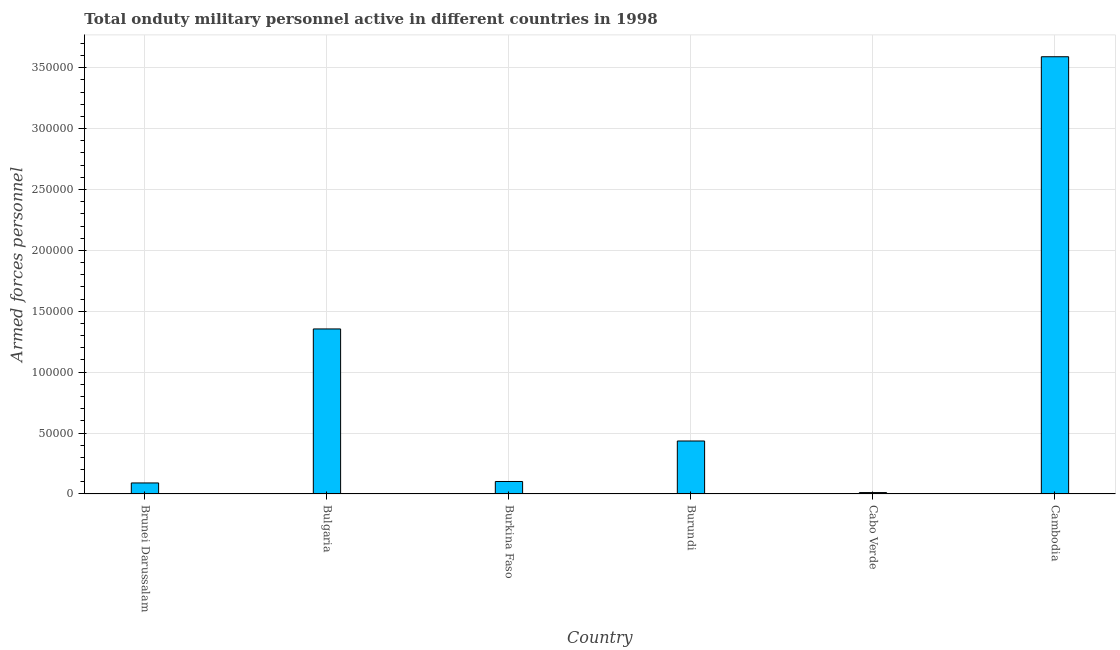Does the graph contain any zero values?
Give a very brief answer. No. What is the title of the graph?
Give a very brief answer. Total onduty military personnel active in different countries in 1998. What is the label or title of the X-axis?
Ensure brevity in your answer.  Country. What is the label or title of the Y-axis?
Provide a short and direct response. Armed forces personnel. What is the number of armed forces personnel in Cabo Verde?
Make the answer very short. 1150. Across all countries, what is the maximum number of armed forces personnel?
Ensure brevity in your answer.  3.59e+05. Across all countries, what is the minimum number of armed forces personnel?
Ensure brevity in your answer.  1150. In which country was the number of armed forces personnel maximum?
Offer a terse response. Cambodia. In which country was the number of armed forces personnel minimum?
Your answer should be very brief. Cabo Verde. What is the sum of the number of armed forces personnel?
Offer a terse response. 5.58e+05. What is the difference between the number of armed forces personnel in Brunei Darussalam and Burundi?
Your answer should be compact. -3.44e+04. What is the average number of armed forces personnel per country?
Offer a terse response. 9.31e+04. What is the median number of armed forces personnel?
Provide a short and direct response. 2.69e+04. What is the ratio of the number of armed forces personnel in Burkina Faso to that in Cabo Verde?
Your answer should be very brief. 8.91. What is the difference between the highest and the second highest number of armed forces personnel?
Your answer should be very brief. 2.24e+05. Is the sum of the number of armed forces personnel in Burundi and Cabo Verde greater than the maximum number of armed forces personnel across all countries?
Give a very brief answer. No. What is the difference between the highest and the lowest number of armed forces personnel?
Keep it short and to the point. 3.58e+05. How many bars are there?
Offer a very short reply. 6. Are all the bars in the graph horizontal?
Make the answer very short. No. How many countries are there in the graph?
Provide a short and direct response. 6. Are the values on the major ticks of Y-axis written in scientific E-notation?
Ensure brevity in your answer.  No. What is the Armed forces personnel of Brunei Darussalam?
Make the answer very short. 9050. What is the Armed forces personnel of Bulgaria?
Offer a terse response. 1.36e+05. What is the Armed forces personnel of Burkina Faso?
Offer a very short reply. 1.02e+04. What is the Armed forces personnel of Burundi?
Make the answer very short. 4.35e+04. What is the Armed forces personnel in Cabo Verde?
Provide a succinct answer. 1150. What is the Armed forces personnel in Cambodia?
Give a very brief answer. 3.59e+05. What is the difference between the Armed forces personnel in Brunei Darussalam and Bulgaria?
Offer a terse response. -1.26e+05. What is the difference between the Armed forces personnel in Brunei Darussalam and Burkina Faso?
Make the answer very short. -1200. What is the difference between the Armed forces personnel in Brunei Darussalam and Burundi?
Your response must be concise. -3.44e+04. What is the difference between the Armed forces personnel in Brunei Darussalam and Cabo Verde?
Ensure brevity in your answer.  7900. What is the difference between the Armed forces personnel in Brunei Darussalam and Cambodia?
Ensure brevity in your answer.  -3.50e+05. What is the difference between the Armed forces personnel in Bulgaria and Burkina Faso?
Offer a terse response. 1.25e+05. What is the difference between the Armed forces personnel in Bulgaria and Burundi?
Your answer should be compact. 9.20e+04. What is the difference between the Armed forces personnel in Bulgaria and Cabo Verde?
Keep it short and to the point. 1.34e+05. What is the difference between the Armed forces personnel in Bulgaria and Cambodia?
Your answer should be compact. -2.24e+05. What is the difference between the Armed forces personnel in Burkina Faso and Burundi?
Your answer should be compact. -3.32e+04. What is the difference between the Armed forces personnel in Burkina Faso and Cabo Verde?
Your answer should be compact. 9100. What is the difference between the Armed forces personnel in Burkina Faso and Cambodia?
Your answer should be very brief. -3.49e+05. What is the difference between the Armed forces personnel in Burundi and Cabo Verde?
Keep it short and to the point. 4.24e+04. What is the difference between the Armed forces personnel in Burundi and Cambodia?
Provide a short and direct response. -3.16e+05. What is the difference between the Armed forces personnel in Cabo Verde and Cambodia?
Make the answer very short. -3.58e+05. What is the ratio of the Armed forces personnel in Brunei Darussalam to that in Bulgaria?
Give a very brief answer. 0.07. What is the ratio of the Armed forces personnel in Brunei Darussalam to that in Burkina Faso?
Offer a very short reply. 0.88. What is the ratio of the Armed forces personnel in Brunei Darussalam to that in Burundi?
Your answer should be very brief. 0.21. What is the ratio of the Armed forces personnel in Brunei Darussalam to that in Cabo Verde?
Your response must be concise. 7.87. What is the ratio of the Armed forces personnel in Brunei Darussalam to that in Cambodia?
Provide a succinct answer. 0.03. What is the ratio of the Armed forces personnel in Bulgaria to that in Burkina Faso?
Keep it short and to the point. 13.22. What is the ratio of the Armed forces personnel in Bulgaria to that in Burundi?
Offer a very short reply. 3.12. What is the ratio of the Armed forces personnel in Bulgaria to that in Cabo Verde?
Offer a very short reply. 117.83. What is the ratio of the Armed forces personnel in Bulgaria to that in Cambodia?
Offer a terse response. 0.38. What is the ratio of the Armed forces personnel in Burkina Faso to that in Burundi?
Make the answer very short. 0.24. What is the ratio of the Armed forces personnel in Burkina Faso to that in Cabo Verde?
Offer a very short reply. 8.91. What is the ratio of the Armed forces personnel in Burkina Faso to that in Cambodia?
Provide a succinct answer. 0.03. What is the ratio of the Armed forces personnel in Burundi to that in Cabo Verde?
Offer a terse response. 37.83. What is the ratio of the Armed forces personnel in Burundi to that in Cambodia?
Your response must be concise. 0.12. What is the ratio of the Armed forces personnel in Cabo Verde to that in Cambodia?
Offer a terse response. 0. 